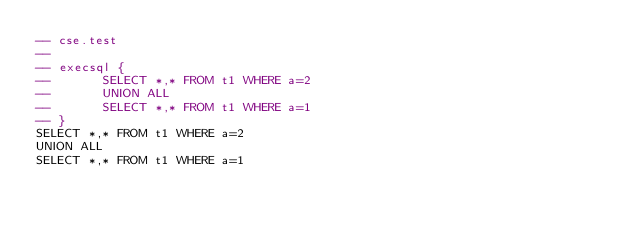Convert code to text. <code><loc_0><loc_0><loc_500><loc_500><_SQL_>-- cse.test
-- 
-- execsql {
--       SELECT *,* FROM t1 WHERE a=2
--       UNION ALL
--       SELECT *,* FROM t1 WHERE a=1
-- }
SELECT *,* FROM t1 WHERE a=2
UNION ALL
SELECT *,* FROM t1 WHERE a=1</code> 